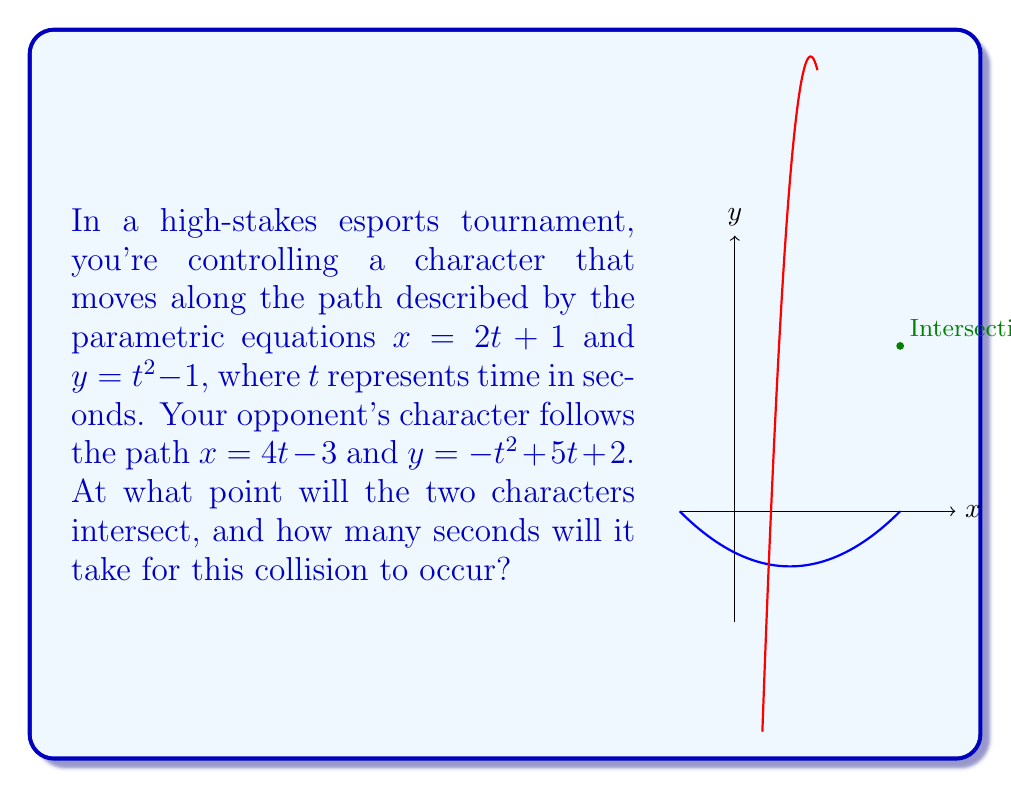Help me with this question. Let's solve this step-by-step:

1) For the characters to intersect, their x and y coordinates must be equal at the same time t. So we need to solve the system of equations:

   $$2t + 1 = 4t - 3$$
   $$t^2 - 1 = -t^2 + 5t + 2$$

2) From the first equation:
   $$2t + 1 = 4t - 3$$
   $$4 = 2t$$
   $$t = 2$$

3) Let's verify if this t satisfies the second equation:
   $$(2)^2 - 1 = -(2)^2 + 5(2) + 2$$
   $$4 - 1 = -4 + 10 + 2$$
   $$3 = 8$$

   This is not true, so $t = 2$ is not the solution.

4) Let's solve the second equation:
   $$t^2 - 1 = -t^2 + 5t + 2$$
   $$2t^2 = 5t + 3$$
   $$2t^2 - 5t - 3 = 0$$

5) This is a quadratic equation. We can solve it using the quadratic formula:
   $$t = \frac{-b \pm \sqrt{b^2 - 4ac}}{2a}$$
   where $a = 2$, $b = -5$, and $c = -3$

6) Plugging in these values:
   $$t = \frac{5 \pm \sqrt{(-5)^2 - 4(2)(-3)}}{2(2)}$$
   $$t = \frac{5 \pm \sqrt{25 + 24}}{4}$$
   $$t = \frac{5 \pm 7}{4}$$

7) This gives us two solutions:
   $$t = \frac{5 + 7}{4} = 3$$ or $$t = \frac{5 - 7}{4} = -\frac{1}{2}$$

8) Since time cannot be negative in this context, we take $t = 3$.

9) To find the intersection point, we plug $t = 3$ into either set of parametric equations:
   $$x = 2(3) + 1 = 7$$
   $$y = 3^2 - 1 = 8$$

Therefore, the characters will intersect at the point (7, 8) after 3 seconds.
Answer: (7, 8) after 3 seconds 